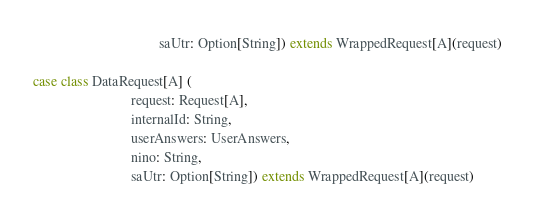Convert code to text. <code><loc_0><loc_0><loc_500><loc_500><_Scala_>                                    saUtr: Option[String]) extends WrappedRequest[A](request)

case class DataRequest[A] (
                            request: Request[A],
                            internalId: String,
                            userAnswers: UserAnswers,
                            nino: String,
                            saUtr: Option[String]) extends WrappedRequest[A](request)
</code> 